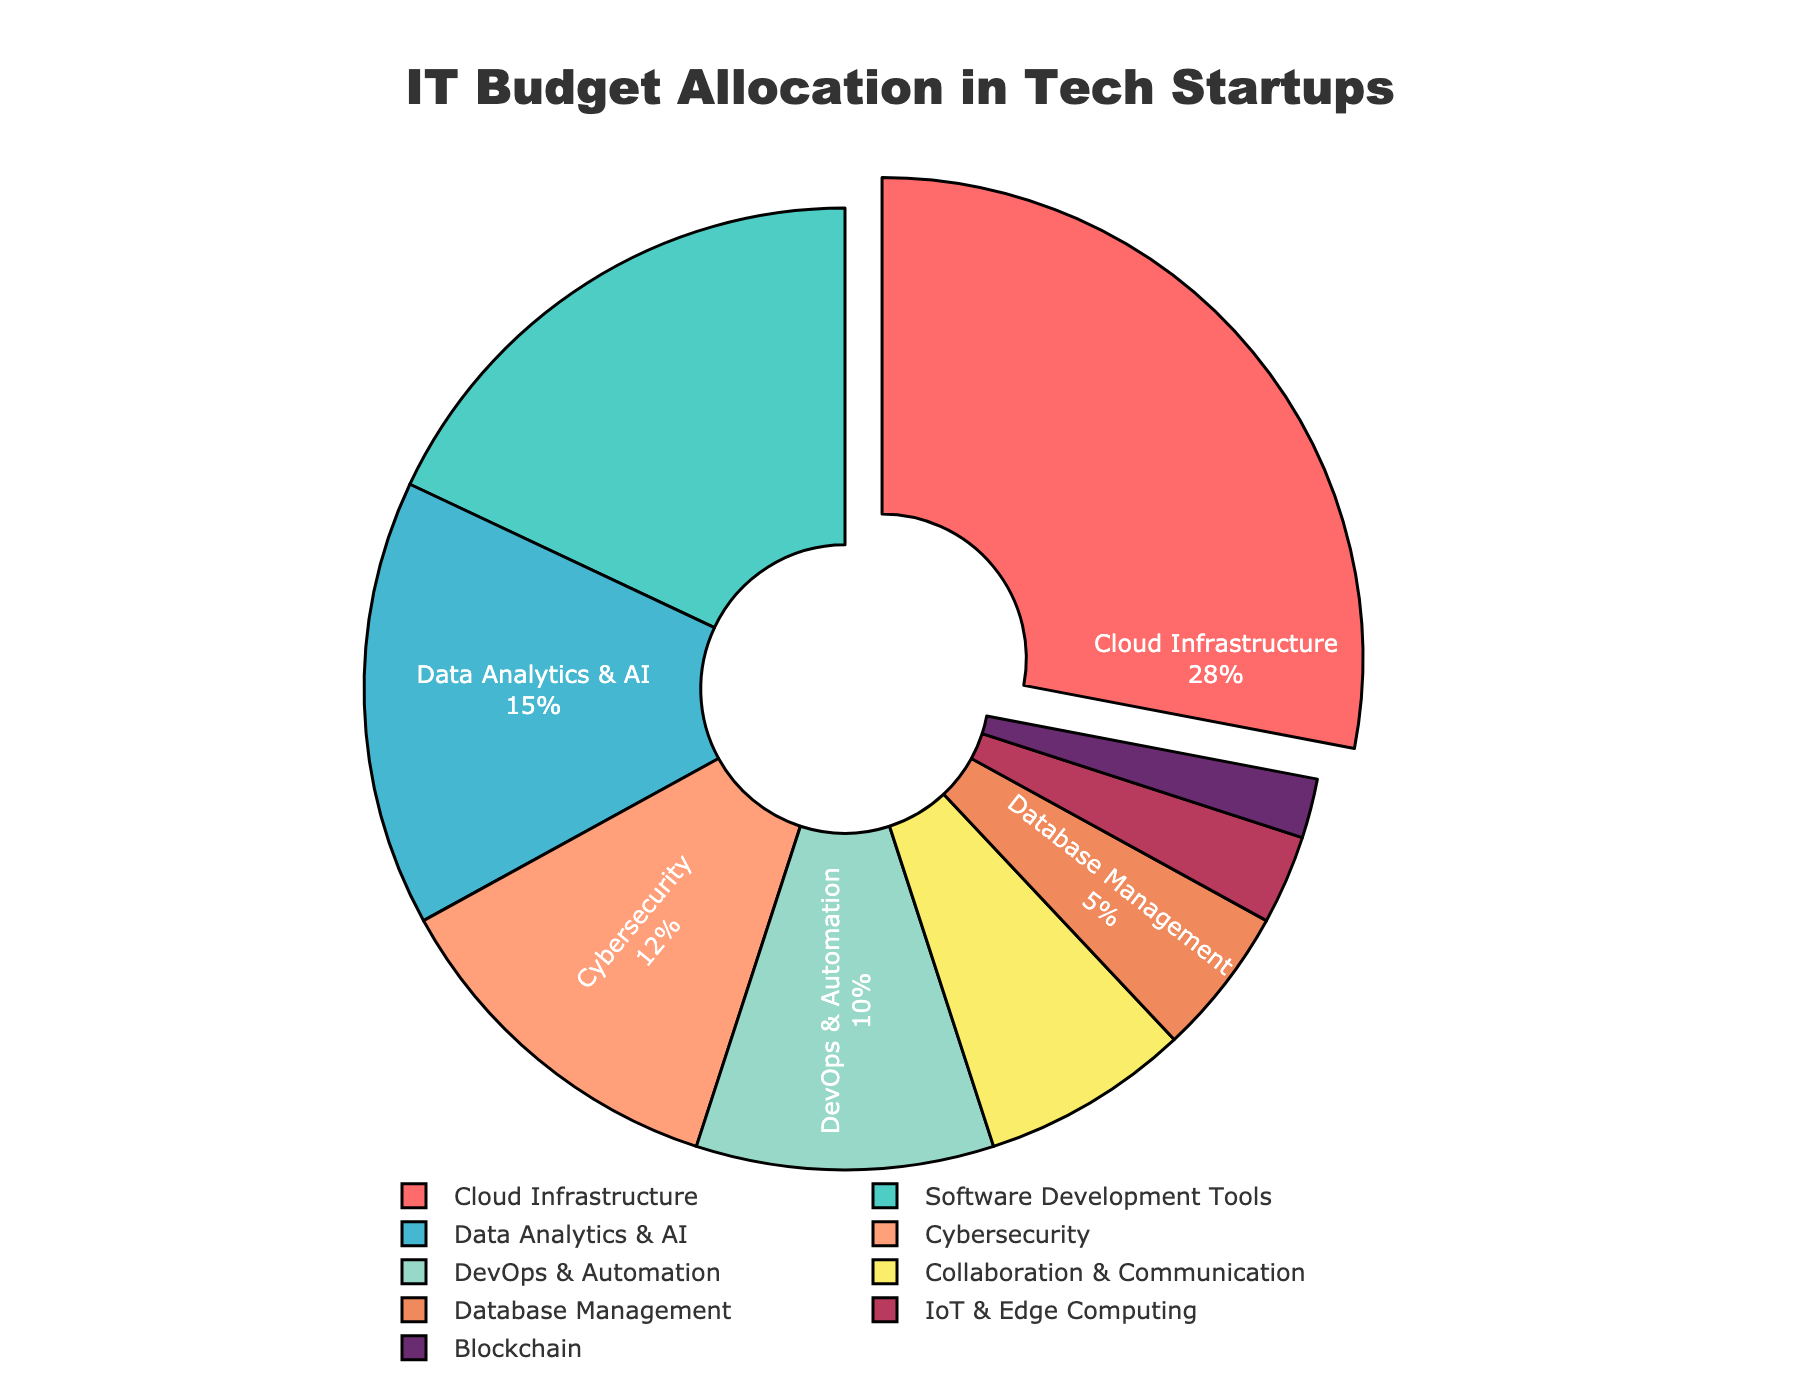What's the largest portion of the IT budget allocated to? The largest section of the pie chart is pulled out for emphasis and corresponds to "Cloud Infrastructure" with a percentage of 28%.
Answer: Cloud Infrastructure Which category receives the least funding? The smallest section of the pie chart is labeled "Blockchain" with a percentage of 2%.
Answer: Blockchain How much more is allocated to Software Development Tools than to Data Analytics & AI? Software Development Tools receive 18% and Data Analytics & AI receive 15%. The difference is 18% - 15% = 3%.
Answer: 3% What is the combined percentage allocation for Cybersecurity and DevOps & Automation? Cybersecurity has 12%, and DevOps & Automation has 10%. The combined allocation is 12% + 10% = 22%.
Answer: 22% How many categories have an allocation of 10% or higher? By examining the chart, categories with 10% or higher are: Cloud Infrastructure, Software Development Tools, Data Analytics & AI, Cybersecurity, and DevOps & Automation. There are 5 such categories.
Answer: 5 Is Cybersecurity allocated more budget than Collaboration & Communication? Cybersecurity has a 12% allocation, while Collaboration & Communication has 7%. Since 12% is more than 7%, the answer is yes.
Answer: Yes What is the visual indicator used to highlight the category with the highest allocation? The pie chart pulls out the section corresponding to the highest allocation to highlight it. This section corresponds to "Cloud Infrastructure".
Answer: Pulled out section What percentage more is allocated to DevOps & Automation compared to IoT & Edge Computing? DevOps & Automation receive 10%, while IoT & Edge Computing receive 3%. The percentage difference is 10% - 3% = 7%.
Answer: 7% Which color is used for the section representing Database Management? The color used for the Database Management section is visually distinct and corresponds to a color like "#F08A5D" (though described in natural language as a shade of orange/brown).
Answer: Orange/Brown What is the combined percentage for categories with single-digit budget allocations? Single-digit budget allocations are for Collaboration & Communication (7%), Database Management (5%), IoT & Edge Computing (3%), and Blockchain (2%). Their combined total is 7% + 5% + 3% + 2% = 17%.
Answer: 17% 